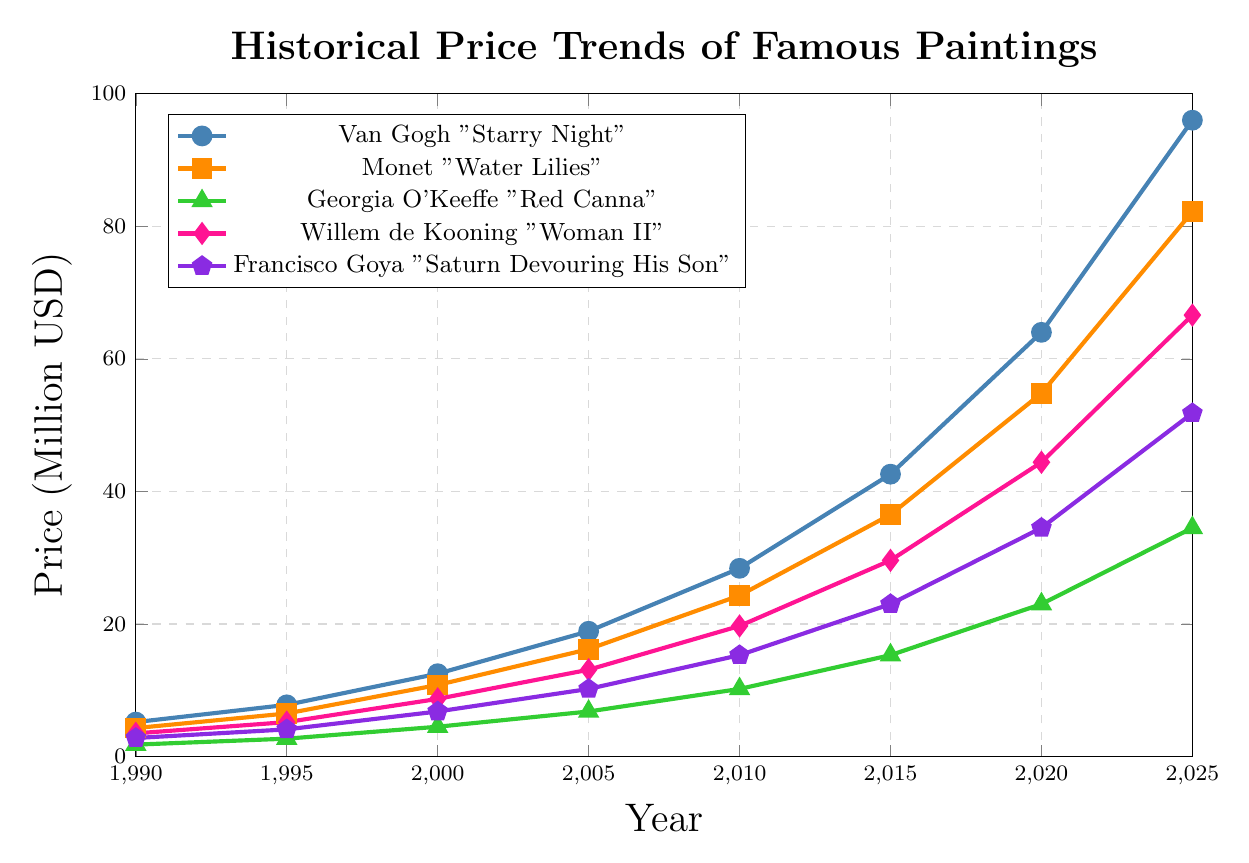Which painting had the highest price in 2020? Look at the y-axis value in the year 2020 for each painting. Van Gogh's "Starry Night" had the highest value of 64 million USD.
Answer: Van Gogh "Starry Night" From 1990 to 2025, which painting experienced the greatest increase in price? Calculate the price difference from 1990 to 2025 for each painting: Van Gogh (96-5.2 = 90.8), Monet (82.2-4.3 = 77.9), O'Keeffe (34.5-1.8 = 32.7), de Kooning (66.6-3.5 = 63.1), Goya (51.8-2.8 = 49). Van Gogh's "Starry Night" had the greatest increase of 90.8 million USD.
Answer: Van Gogh "Starry Night" Which painting's value increased the least between 2000 and 2010? Calculate the price difference from 2000 to 2010 for each painting: Van Gogh (28.4-12.5 = 15.9), Monet (24.3-10.8 = 13.5), O'Keeffe (10.2-4.5 = 5.7), de Kooning (19.7-8.7 = 11), Goya (15.3-6.8 = 8.5). Georgia O'Keeffe's "Red Canna" had the smallest increase of 5.7 million USD.
Answer: Georgia O'Keeffe "Red Canna" How much more expensive was the "Water Lilies" by Monet than "Woman II" by de Kooning in 2005? Find the prices of both paintings in 2005: Monet (16.2 million), de Kooning (13.1 million). The difference is 16.2 - 13.1 = 3.1 million USD.
Answer: 3.1 million USD Which two paintings had the closest price difference in 2015? Calculate the price difference between each pair: Van Gogh vs Monet (42.6-36.5=6.1), Van Gogh vs O'Keeffe (42.6-15.3=27.3), Van Gogh vs de Kooning (42.6-29.6=13), Van Gogh vs Goya (42.6-23=19.6), Monet vs O'Keeffe (36.5-15.3=21.2), Monet vs de Kooning (36.5-29.6=6.9), Monet vs Goya (36.5-23=13.5), O'Keeffe vs de Kooning (15.3-29.6=14.3), O'Keeffe vs Goya (15.3-23=7.7), de Kooning vs Goya (29.6-23=6.6). The closest difference is between Van Gogh's "Starry Night" and Monet's "Water Lilies", with a difference of 6.1 million USD.
Answer: Van Gogh and Monet What is the total price of all paintings in 2000? Sum the prices of all paintings in 2000: Van Gogh (12.5), Monet (10.8), O'Keeffe (4.5), de Kooning (8.7), Goya (6.8). Total is 12.5 + 10.8 + 4.5 + 8.7 + 6.8 = 43.3 million USD.
Answer: 43.3 million USD Which painting had the highest average annual price increase from 2010 to 2025? Calculate the annual average increase: Van Gogh (96-28.4)/15 = 4.5 per year, Monet (82.2-24.3)/15 = 3.86 per year, O'Keeffe (34.5-10.2)/15 = 1.62 per year, de Kooning (66.6-19.7)/15 = 3.12 per year, Goya (51.8-15.3)/15 = 2.44 per year. Van Gogh's "Starry Night" had the highest average annual increase of 4.5 million USD.
Answer: Van Gogh "Starry Night" Which painting surpassed the 10 million USD mark first? Observe the data points for each painting and find the earliest year a painting surpasses 10 million USD. Van Gogh "Starry Night" surpassed 10 million USD in 2000.
Answer: Van Gogh "Starry Night" How many paintings had prices surpassing 50 million USD in 2020? Look at the prices in 2020: Van Gogh (64), Monet (54.8), O'Keeffe (23), de Kooning (44.4), Goya (34.5). Two paintings, Van Gogh and Monet, surpassed 50 million USD.
Answer: 2 Compare the visual lengths of the lines for "Starry Night" and "Water Lilies". Which one has a steeper gradient? Assess the visual steepness by looking at the slope of the line segments. "Starry Night" by Van Gogh has a steeper gradient as it increases more sharply than "Water Lilies" by Monet.
Answer: Van Gogh "Starry Night" 